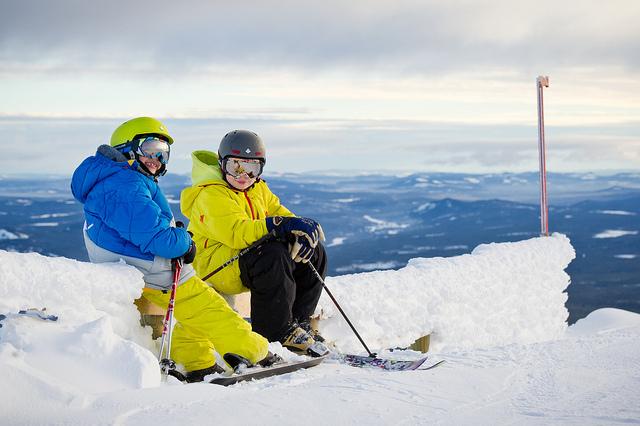What do they wear to keep their heads warm?
Answer briefly. Helmets. Are both people skiing?
Concise answer only. Yes. What are the people doing?
Answer briefly. Sitting. Is visibility good?
Give a very brief answer. Yes. What color is the jacket?
Concise answer only. Yellow. 